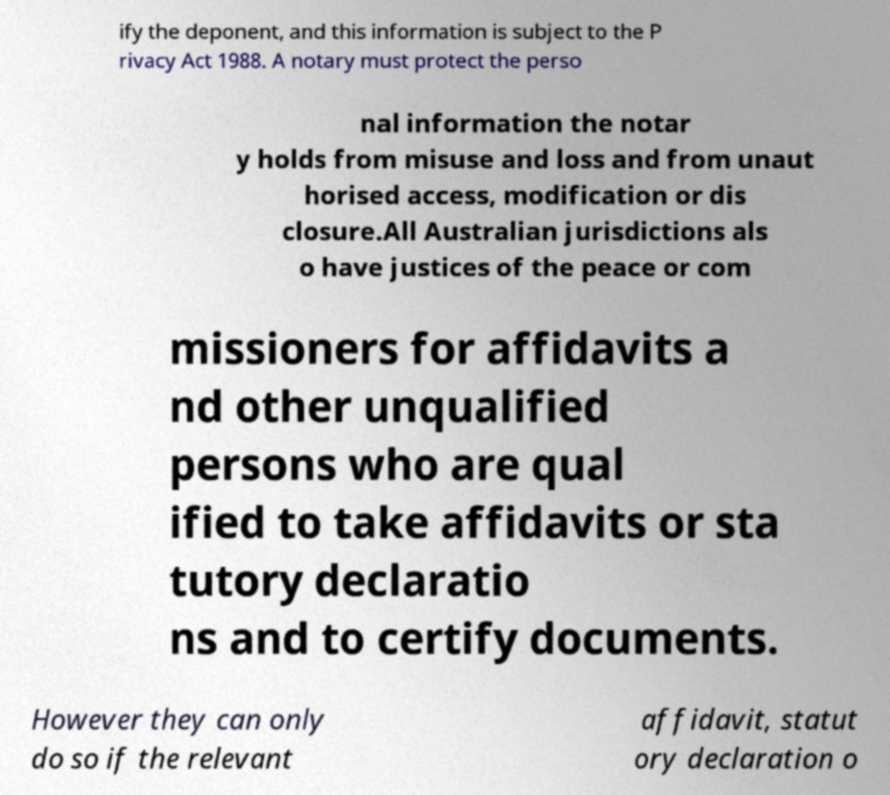Can you accurately transcribe the text from the provided image for me? ify the deponent, and this information is subject to the P rivacy Act 1988. A notary must protect the perso nal information the notar y holds from misuse and loss and from unaut horised access, modification or dis closure.All Australian jurisdictions als o have justices of the peace or com missioners for affidavits a nd other unqualified persons who are qual ified to take affidavits or sta tutory declaratio ns and to certify documents. However they can only do so if the relevant affidavit, statut ory declaration o 